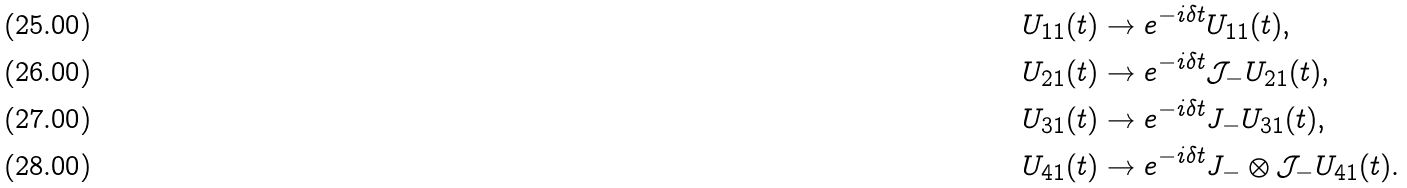<formula> <loc_0><loc_0><loc_500><loc_500>U _ { 1 1 } ( t ) & \rightarrow e ^ { - i \delta t } U _ { 1 1 } ( t ) , \\ U _ { 2 1 } ( t ) & \rightarrow e ^ { - i \delta t } \mathcal { J } _ { - } U _ { 2 1 } ( t ) , \\ U _ { 3 1 } ( t ) & \rightarrow e ^ { - i \delta t } J _ { - } U _ { 3 1 } ( t ) , \\ U _ { 4 1 } ( t ) & \rightarrow e ^ { - i \delta t } J _ { - } \otimes \mathcal { J } _ { - } U _ { 4 1 } ( t ) .</formula> 